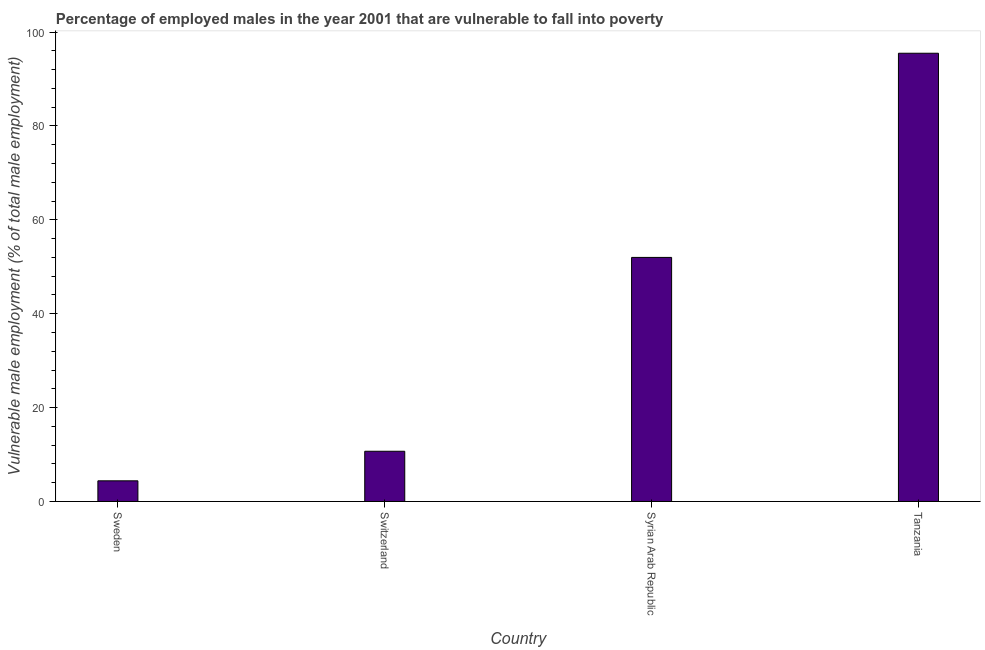Does the graph contain any zero values?
Keep it short and to the point. No. Does the graph contain grids?
Give a very brief answer. No. What is the title of the graph?
Ensure brevity in your answer.  Percentage of employed males in the year 2001 that are vulnerable to fall into poverty. What is the label or title of the Y-axis?
Give a very brief answer. Vulnerable male employment (% of total male employment). What is the percentage of employed males who are vulnerable to fall into poverty in Sweden?
Offer a very short reply. 4.4. Across all countries, what is the maximum percentage of employed males who are vulnerable to fall into poverty?
Keep it short and to the point. 95.5. Across all countries, what is the minimum percentage of employed males who are vulnerable to fall into poverty?
Provide a succinct answer. 4.4. In which country was the percentage of employed males who are vulnerable to fall into poverty maximum?
Offer a terse response. Tanzania. In which country was the percentage of employed males who are vulnerable to fall into poverty minimum?
Offer a terse response. Sweden. What is the sum of the percentage of employed males who are vulnerable to fall into poverty?
Make the answer very short. 162.6. What is the difference between the percentage of employed males who are vulnerable to fall into poverty in Syrian Arab Republic and Tanzania?
Your answer should be very brief. -43.5. What is the average percentage of employed males who are vulnerable to fall into poverty per country?
Keep it short and to the point. 40.65. What is the median percentage of employed males who are vulnerable to fall into poverty?
Offer a very short reply. 31.35. In how many countries, is the percentage of employed males who are vulnerable to fall into poverty greater than 20 %?
Make the answer very short. 2. What is the ratio of the percentage of employed males who are vulnerable to fall into poverty in Switzerland to that in Tanzania?
Make the answer very short. 0.11. What is the difference between the highest and the second highest percentage of employed males who are vulnerable to fall into poverty?
Your answer should be compact. 43.5. What is the difference between the highest and the lowest percentage of employed males who are vulnerable to fall into poverty?
Give a very brief answer. 91.1. How many countries are there in the graph?
Your response must be concise. 4. What is the difference between two consecutive major ticks on the Y-axis?
Ensure brevity in your answer.  20. Are the values on the major ticks of Y-axis written in scientific E-notation?
Your answer should be compact. No. What is the Vulnerable male employment (% of total male employment) of Sweden?
Ensure brevity in your answer.  4.4. What is the Vulnerable male employment (% of total male employment) of Switzerland?
Your answer should be compact. 10.7. What is the Vulnerable male employment (% of total male employment) in Syrian Arab Republic?
Keep it short and to the point. 52. What is the Vulnerable male employment (% of total male employment) in Tanzania?
Offer a very short reply. 95.5. What is the difference between the Vulnerable male employment (% of total male employment) in Sweden and Syrian Arab Republic?
Your answer should be very brief. -47.6. What is the difference between the Vulnerable male employment (% of total male employment) in Sweden and Tanzania?
Your answer should be very brief. -91.1. What is the difference between the Vulnerable male employment (% of total male employment) in Switzerland and Syrian Arab Republic?
Make the answer very short. -41.3. What is the difference between the Vulnerable male employment (% of total male employment) in Switzerland and Tanzania?
Offer a terse response. -84.8. What is the difference between the Vulnerable male employment (% of total male employment) in Syrian Arab Republic and Tanzania?
Provide a short and direct response. -43.5. What is the ratio of the Vulnerable male employment (% of total male employment) in Sweden to that in Switzerland?
Offer a very short reply. 0.41. What is the ratio of the Vulnerable male employment (% of total male employment) in Sweden to that in Syrian Arab Republic?
Your answer should be compact. 0.09. What is the ratio of the Vulnerable male employment (% of total male employment) in Sweden to that in Tanzania?
Your response must be concise. 0.05. What is the ratio of the Vulnerable male employment (% of total male employment) in Switzerland to that in Syrian Arab Republic?
Your answer should be compact. 0.21. What is the ratio of the Vulnerable male employment (% of total male employment) in Switzerland to that in Tanzania?
Keep it short and to the point. 0.11. What is the ratio of the Vulnerable male employment (% of total male employment) in Syrian Arab Republic to that in Tanzania?
Your answer should be compact. 0.55. 